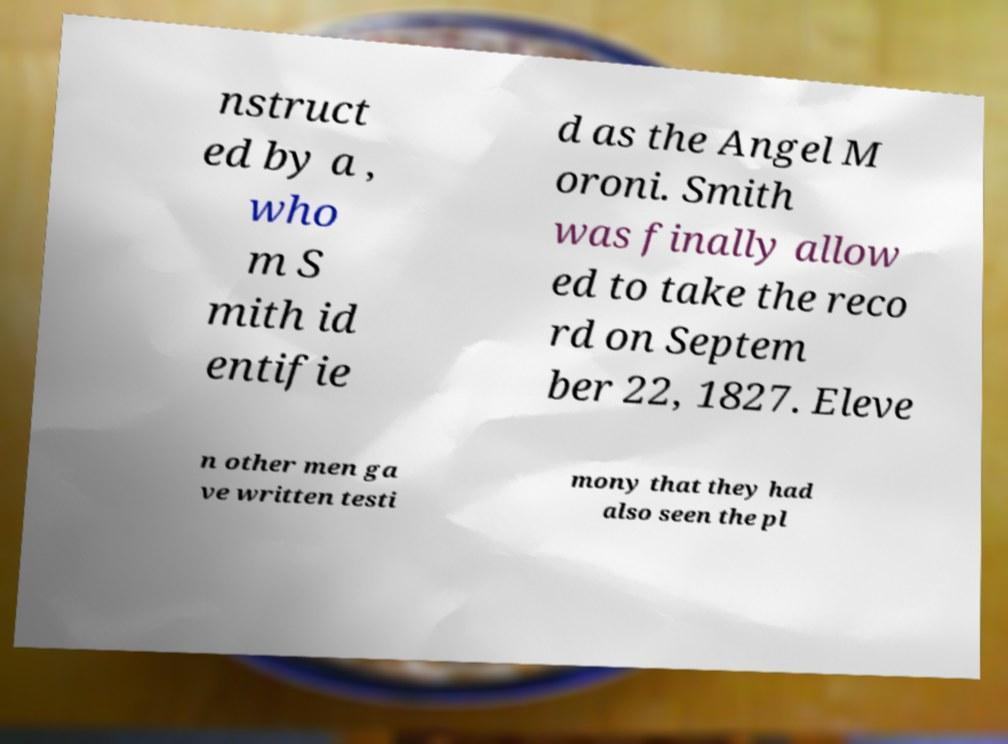I need the written content from this picture converted into text. Can you do that? nstruct ed by a , who m S mith id entifie d as the Angel M oroni. Smith was finally allow ed to take the reco rd on Septem ber 22, 1827. Eleve n other men ga ve written testi mony that they had also seen the pl 